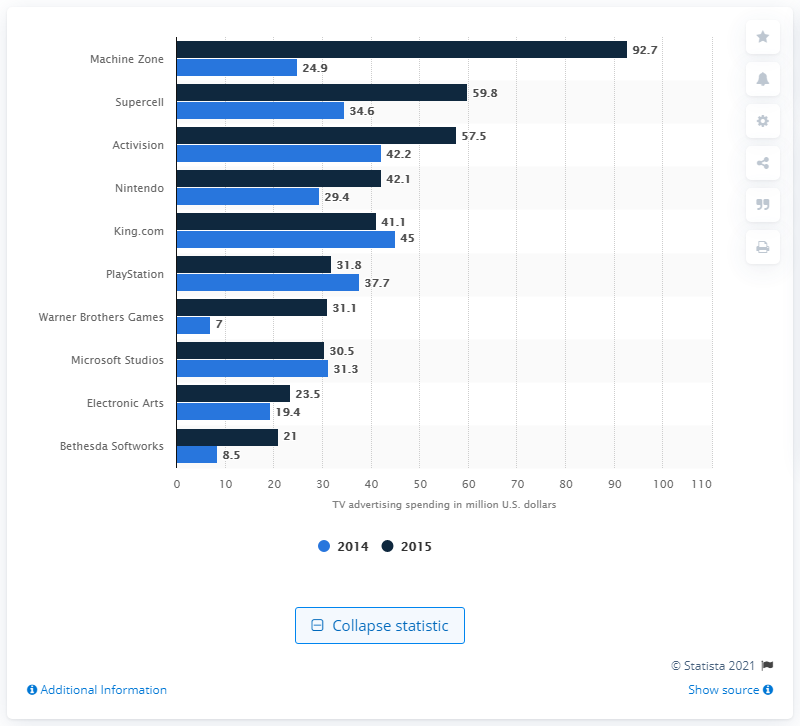Identify some key points in this picture. In 2015, the publisher of "Game of War," Machine Zone, spent 92.7 million U.S. dollars on television advertising. Machine Zone spent $92.7 million on television advertising in 2015. 